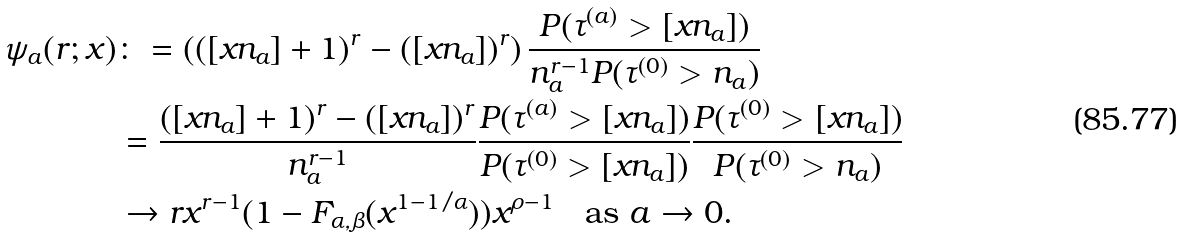Convert formula to latex. <formula><loc_0><loc_0><loc_500><loc_500>\psi _ { a } ( r ; x ) & \colon = \left ( ( [ x n _ { a } ] + 1 ) ^ { r } - ( [ x n _ { a } ] ) ^ { r } \right ) \frac { P ( \tau ^ { ( a ) } > [ x n _ { a } ] ) } { n _ { a } ^ { r - 1 } P ( \tau ^ { ( 0 ) } > n _ { a } ) } \\ & = \frac { ( [ x n _ { a } ] + 1 ) ^ { r } - ( [ x n _ { a } ] ) ^ { r } } { n _ { a } ^ { r - 1 } } \frac { P ( \tau ^ { ( a ) } > [ x n _ { a } ] ) } { P ( \tau ^ { ( 0 ) } > [ x n _ { a } ] ) } \frac { P ( \tau ^ { ( 0 ) } > [ x n _ { a } ] ) } { P ( \tau ^ { ( 0 ) } > n _ { a } ) } \\ & \to r x ^ { r - 1 } ( 1 - F _ { \alpha , \beta } ( x ^ { 1 - 1 / \alpha } ) ) x ^ { \rho - 1 } \quad \text {as } a \to 0 .</formula> 